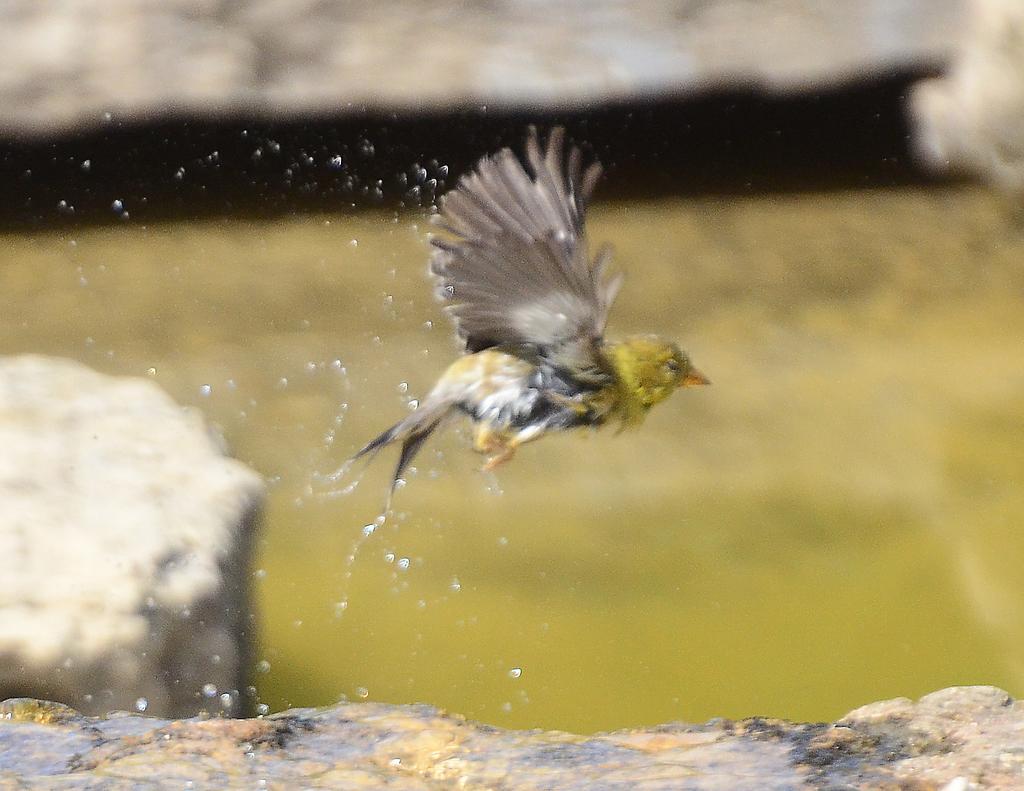Could you give a brief overview of what you see in this image? In this image I can see a bird flying. There are water droplets and the background is blurred. 